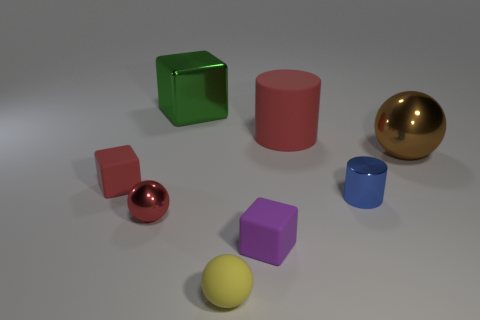What can you infer about the textures of the materials based on the image? Based on the image, the materials with a shiny, reflective surface, like the green cube and the gold sphere, likely have a smooth texture. In contrast, the objects with a matte appearance, such as the red and brown objects, seem to have a rougher texture. Textures can significantly impact how light interacts with objects, and here the differences in shine and reflection suggest differing levels of surface smoothness among the objects. 